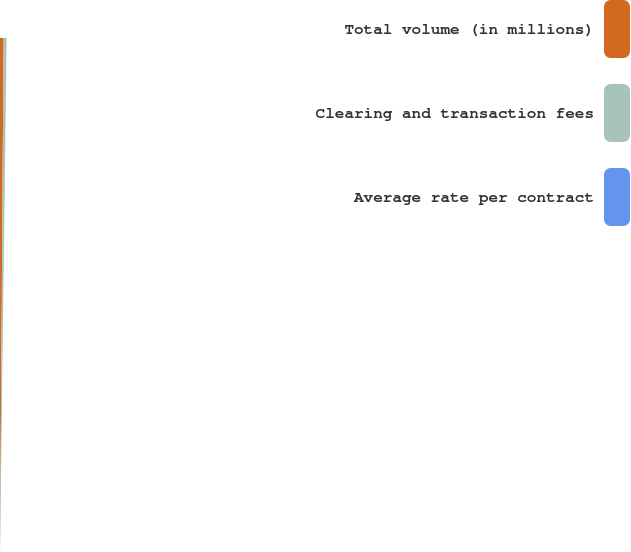<chart> <loc_0><loc_0><loc_500><loc_500><pie_chart><fcel>Total volume (in millions)<fcel>Clearing and transaction fees<fcel>Average rate per contract<nl><fcel>54.45%<fcel>45.53%<fcel>0.02%<nl></chart> 